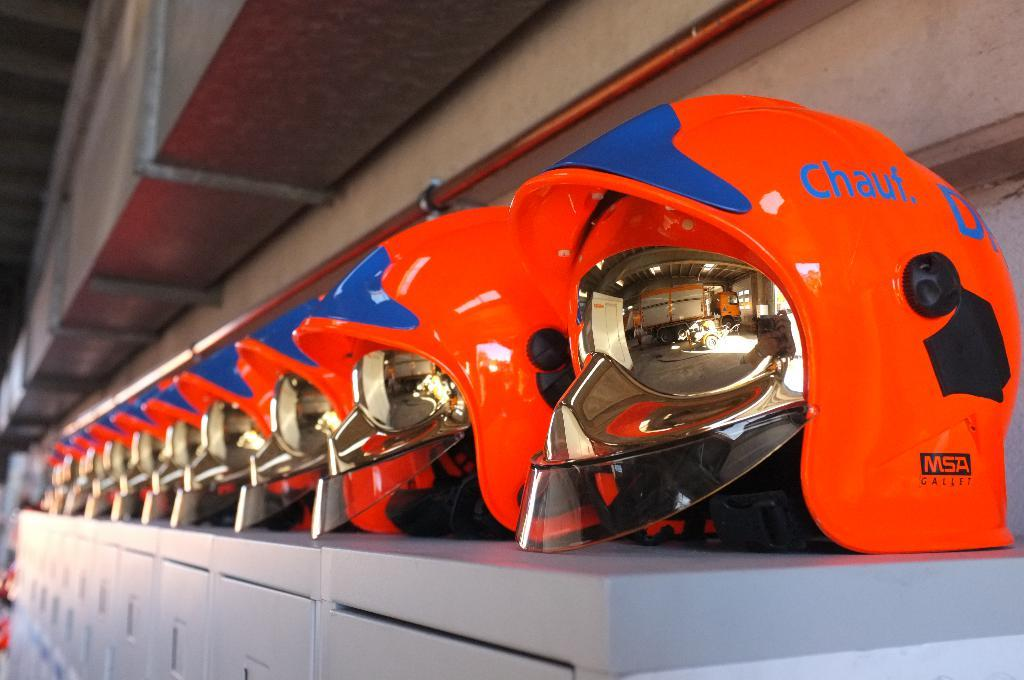What color are the helmets in the image? The helmets in the image are red. What are the helmets placed on top of? The helmets are placed on top of silver color lockers. Can you describe any other objects visible in the image? There is an air conditioner duct visible in the image. What type of relation can be seen between the ladybug and the air conditioner duct in the image? There is no ladybug present in the image, so it is not possible to determine any relation between a ladybug and the air conditioner duct. 